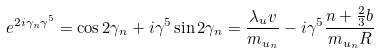<formula> <loc_0><loc_0><loc_500><loc_500>e ^ { 2 i \gamma _ { n } \gamma ^ { 5 } } = \cos { 2 \gamma _ { n } } + i \gamma ^ { 5 } \sin { 2 \gamma _ { n } } = \frac { \lambda _ { u } v } { m _ { u _ { n } } } - i \gamma ^ { 5 } \frac { n + \frac { 2 } { 3 } b } { m _ { u _ { n } } R }</formula> 